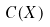Convert formula to latex. <formula><loc_0><loc_0><loc_500><loc_500>C ( X )</formula> 